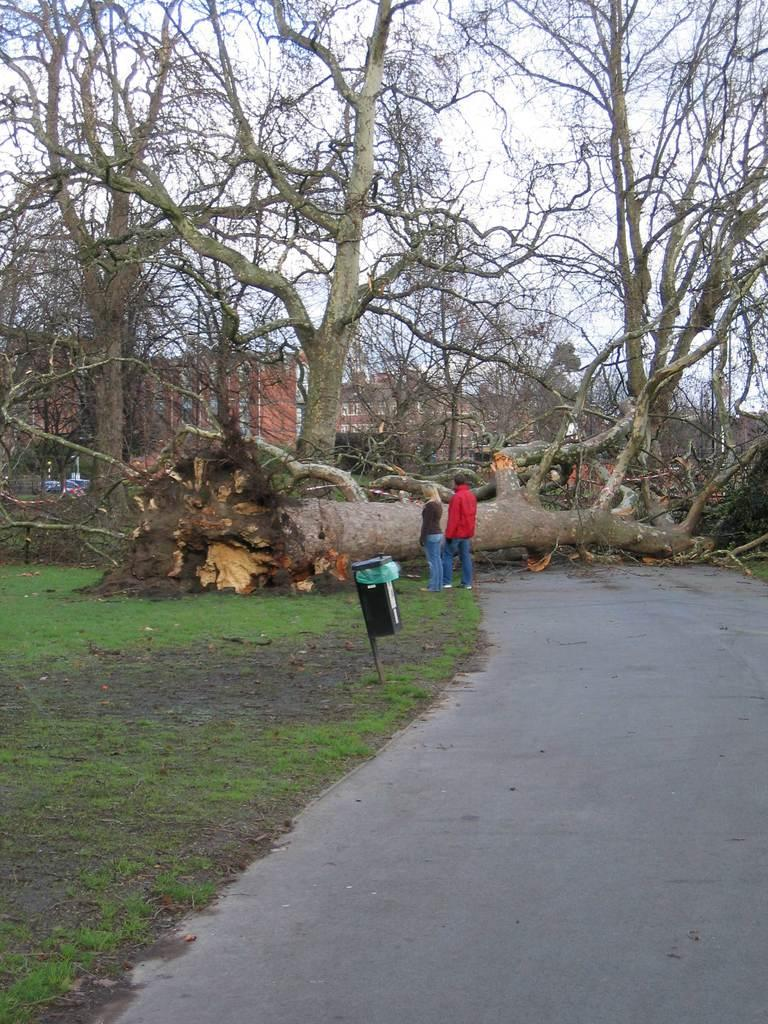What type of surface can be seen in the image? There is a road in the image. What object is present for waste disposal? There is a dustbin in the image. What type of vegetation is visible in the image? There is grass and trees in the image. What type of structures can be seen in the image? There are buildings in the image. How many people are present in the image? There are two persons standing on the ground in the image. What is visible in the background of the image? The sky is visible in the background of the image. Where are the apples growing in the image? There are no apples or trees bearing apples present in the image. What type of alley can be seen in the image? There is no alley present in the image. 